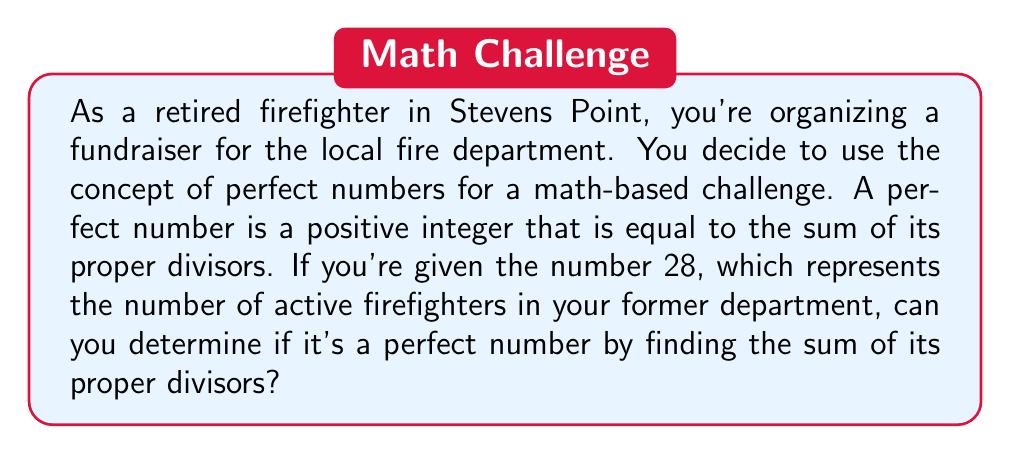Can you answer this question? To determine if 28 is a perfect number, we need to follow these steps:

1. Find all the proper divisors of 28.
2. Calculate the sum of these proper divisors.
3. Compare the sum to the original number.

Step 1: Finding proper divisors of 28
Proper divisors are all positive divisors of a number, excluding the number itself.

To find the divisors, we'll check all numbers from 1 to $\sqrt{28}$:

$\sqrt{28} \approx 5.29$, so we'll check up to 5.

- 1 is always a divisor
- 2 divides 28 (28 ÷ 2 = 14)
- 4 divides 28 (28 ÷ 4 = 7)
- 7 divides 28 (28 ÷ 7 = 4)
- 14 is also a divisor (28 ÷ 14 = 2)

The proper divisors of 28 are: 1, 2, 4, 7, and 14.

Step 2: Calculating the sum of proper divisors
$$ 1 + 2 + 4 + 7 + 14 = 28 $$

Step 3: Comparing the sum to the original number
The sum of the proper divisors (28) is equal to the original number (28).

Therefore, 28 is indeed a perfect number.
Answer: Yes, 28 is a perfect number because the sum of its proper divisors (1 + 2 + 4 + 7 + 14 = 28) is equal to the number itself. 